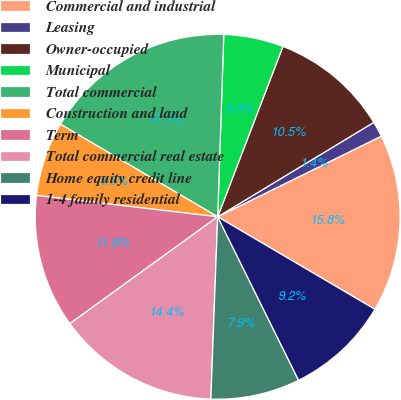<chart> <loc_0><loc_0><loc_500><loc_500><pie_chart><fcel>Commercial and industrial<fcel>Leasing<fcel>Owner-occupied<fcel>Municipal<fcel>Total commercial<fcel>Construction and land<fcel>Term<fcel>Total commercial real estate<fcel>Home equity credit line<fcel>1-4 family residential<nl><fcel>15.75%<fcel>1.37%<fcel>10.52%<fcel>5.29%<fcel>17.06%<fcel>6.6%<fcel>11.83%<fcel>14.44%<fcel>7.91%<fcel>9.22%<nl></chart> 